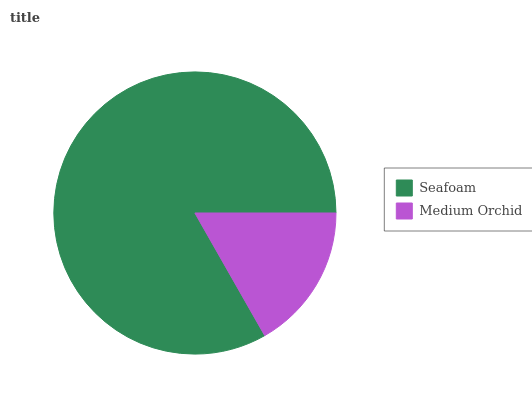Is Medium Orchid the minimum?
Answer yes or no. Yes. Is Seafoam the maximum?
Answer yes or no. Yes. Is Medium Orchid the maximum?
Answer yes or no. No. Is Seafoam greater than Medium Orchid?
Answer yes or no. Yes. Is Medium Orchid less than Seafoam?
Answer yes or no. Yes. Is Medium Orchid greater than Seafoam?
Answer yes or no. No. Is Seafoam less than Medium Orchid?
Answer yes or no. No. Is Seafoam the high median?
Answer yes or no. Yes. Is Medium Orchid the low median?
Answer yes or no. Yes. Is Medium Orchid the high median?
Answer yes or no. No. Is Seafoam the low median?
Answer yes or no. No. 